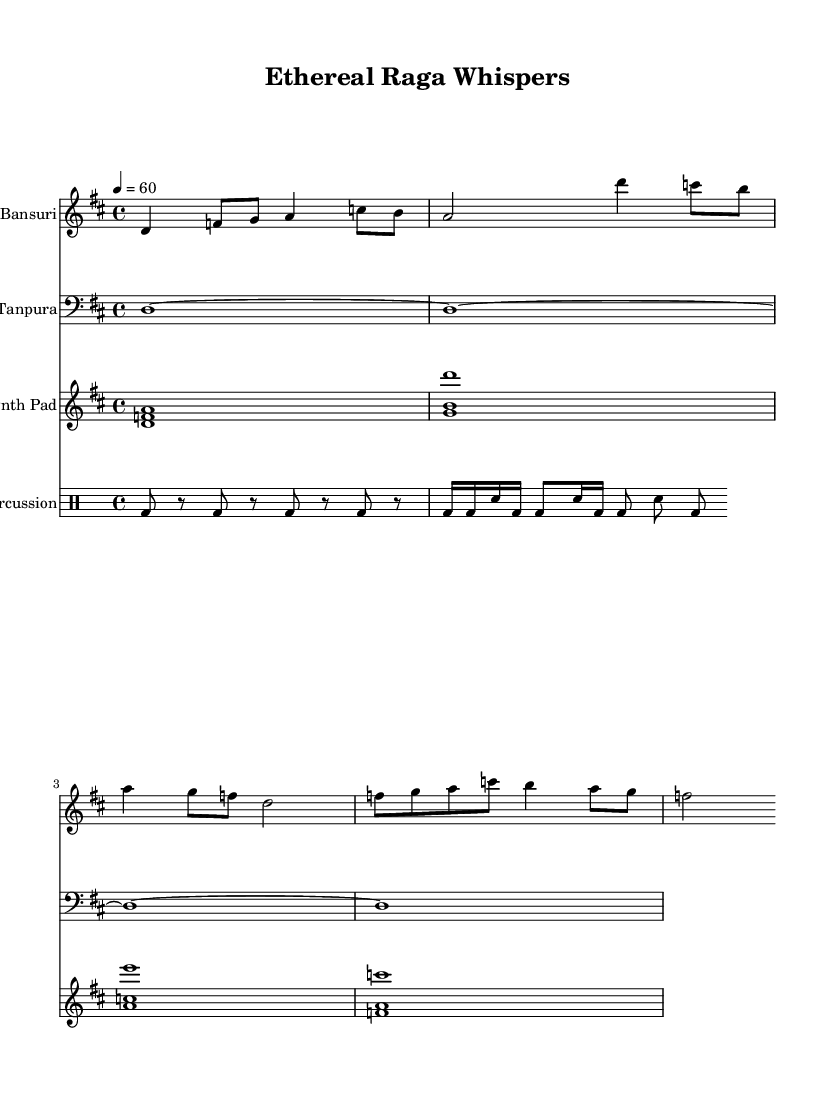What is the key signature of this music? The key signature is indicated right at the beginning of the score, showing one sharp, which corresponds to D major.
Answer: D major What is the time signature of this music? The time signature is displayed at the start, indicated as 4/4, meaning there are four beats in a measure, and the quarter note gets one beat.
Answer: 4/4 What is the tempo marking of this piece? The tempo marking can be found above the staff, set to 60 beats per minute, indicating the speed of the music.
Answer: 60 Which instrument plays the melodic line in this score? The Bansuri is listed at the beginning of the staff as the instrument responsible for the melodic performance, with defined pitches throughout the staff.
Answer: Bansuri How many measures are in the Bansuri part? By counting the distinct groupings in the Bansuri staff, there are four measures visible, each counting distinct rhythmic patterns, making a total of four.
Answer: 4 What type of percussion is used in this arrangement? The percussion part is indicated using standard drum notation, and the bass drum is the primary instrument played throughout the piece.
Answer: Bass drum What is the purpose of the Synth Pad in this composition? The Synth Pad plays sustained chords that add depth and ambiance to the piece, supporting the Bansuri melodies with rich harmonic backing.
Answer: Harmony 